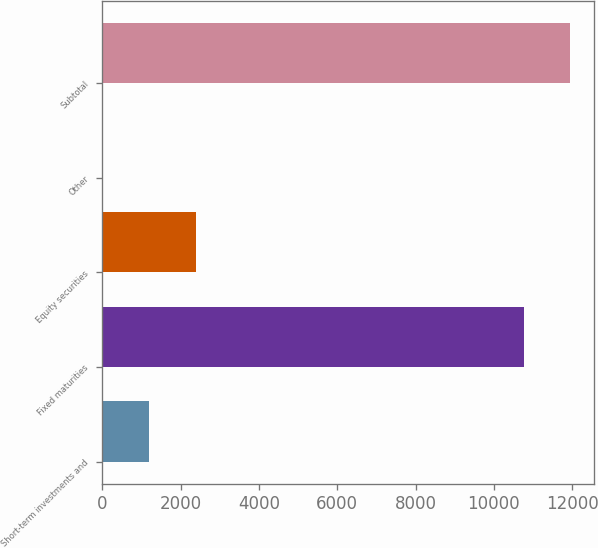<chart> <loc_0><loc_0><loc_500><loc_500><bar_chart><fcel>Short-term investments and<fcel>Fixed maturities<fcel>Equity securities<fcel>Other<fcel>Subtotal<nl><fcel>1203.8<fcel>10764<fcel>2392.6<fcel>15<fcel>11952.8<nl></chart> 